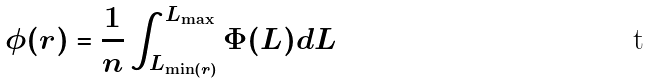Convert formula to latex. <formula><loc_0><loc_0><loc_500><loc_500>\phi ( r ) = \frac { 1 } { n } \int _ { L _ { \min ( r ) } } ^ { L _ { \max } } \Phi ( L ) d L</formula> 